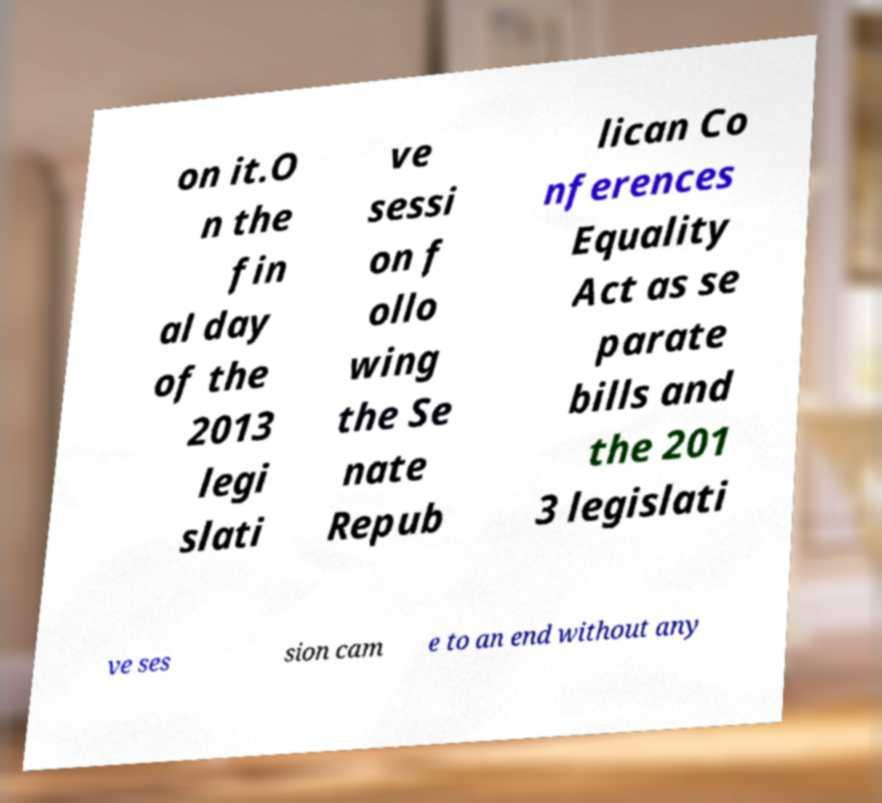I need the written content from this picture converted into text. Can you do that? on it.O n the fin al day of the 2013 legi slati ve sessi on f ollo wing the Se nate Repub lican Co nferences Equality Act as se parate bills and the 201 3 legislati ve ses sion cam e to an end without any 